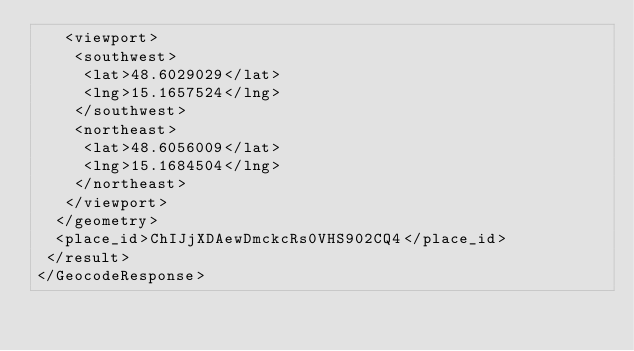Convert code to text. <code><loc_0><loc_0><loc_500><loc_500><_XML_>   <viewport>
    <southwest>
     <lat>48.6029029</lat>
     <lng>15.1657524</lng>
    </southwest>
    <northeast>
     <lat>48.6056009</lat>
     <lng>15.1684504</lng>
    </northeast>
   </viewport>
  </geometry>
  <place_id>ChIJjXDAewDmckcRs0VHS902CQ4</place_id>
 </result>
</GeocodeResponse>
</code> 